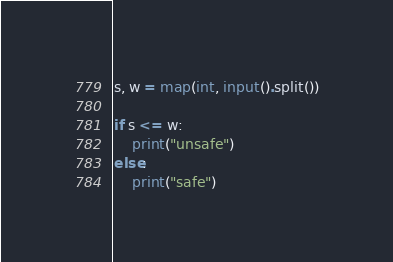Convert code to text. <code><loc_0><loc_0><loc_500><loc_500><_Python_>s, w = map(int, input().split())

if s <= w:
    print("unsafe")
else:
    print("safe")</code> 